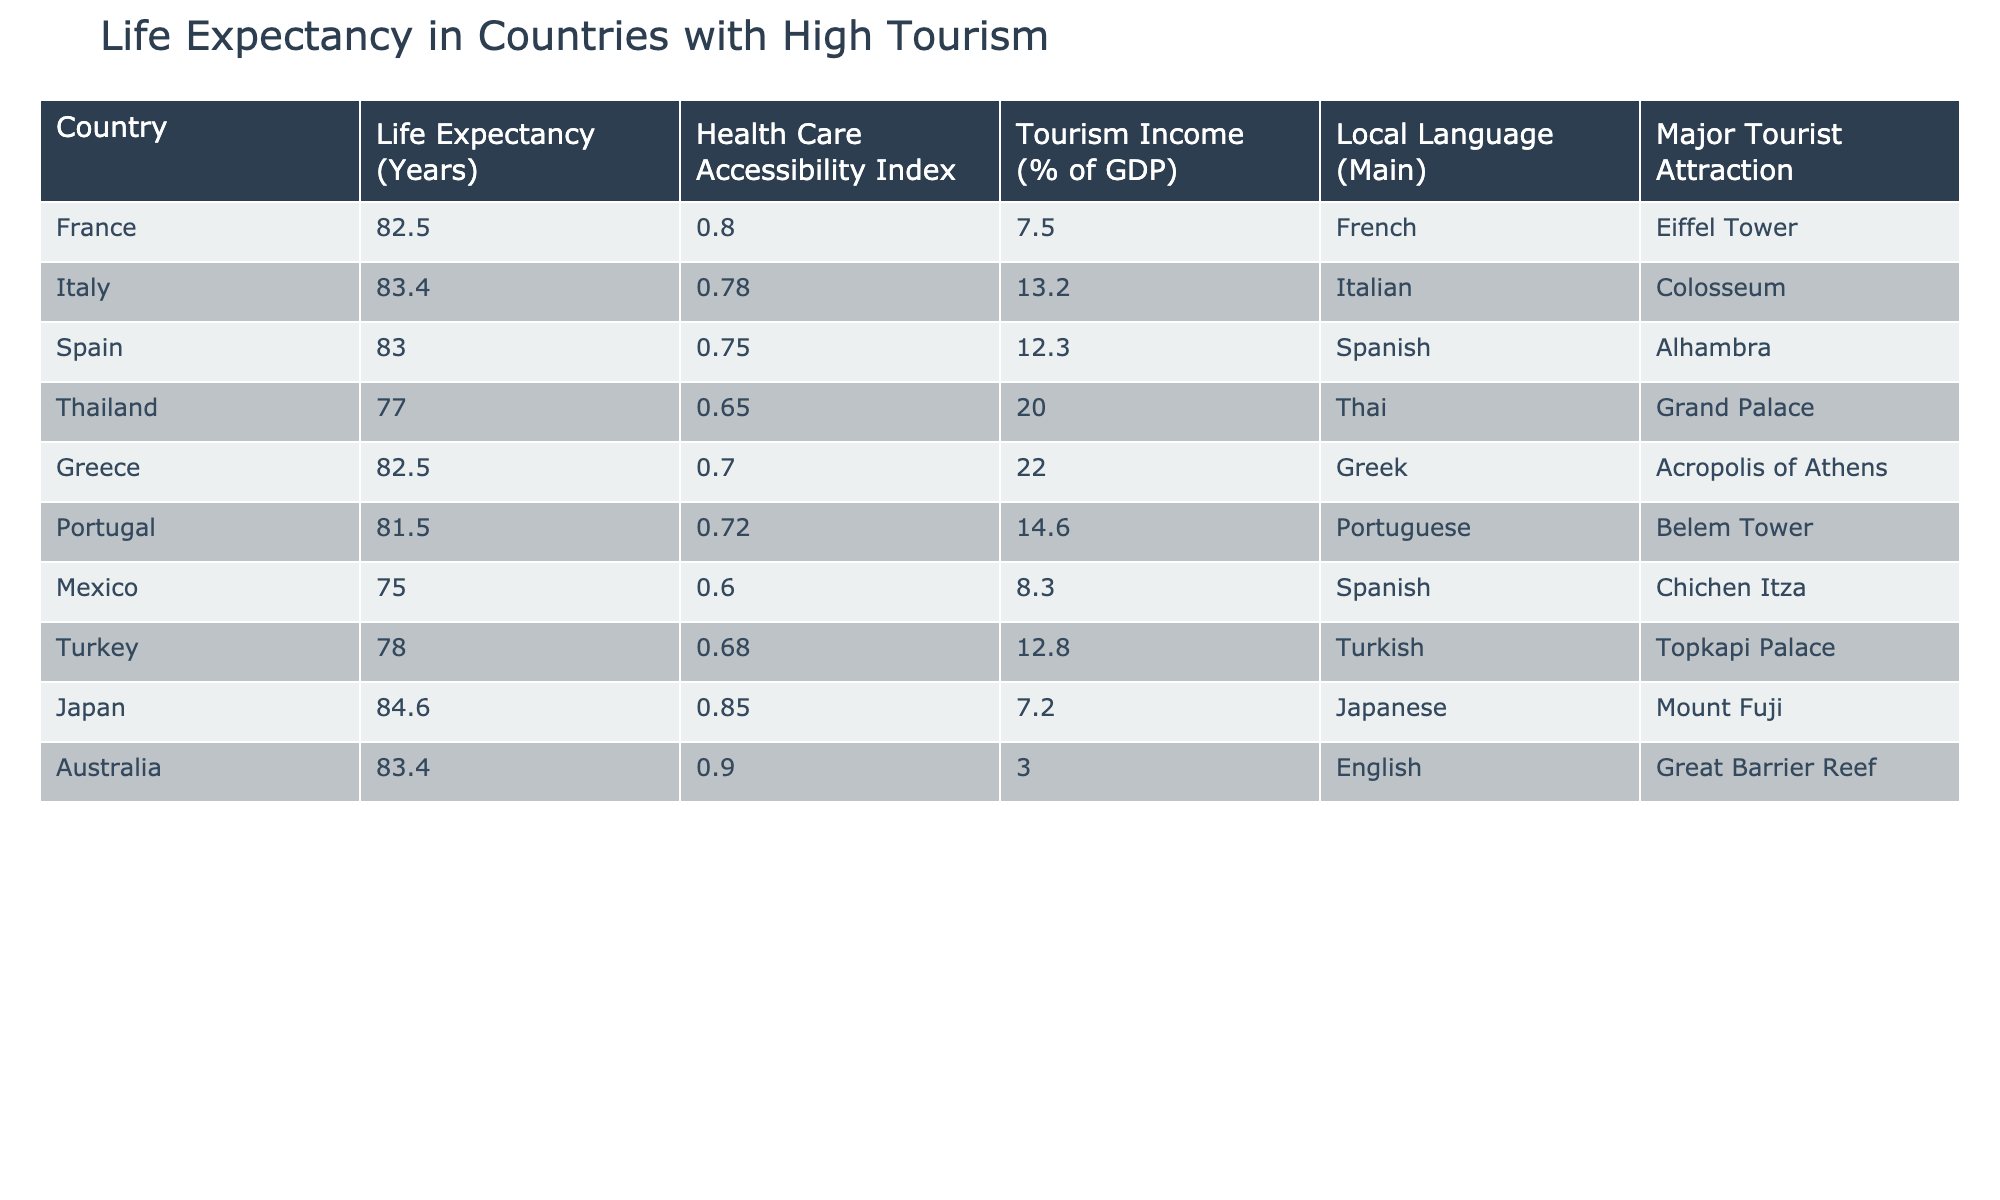What is the life expectancy of Japan? The life expectancy for Japan is directly listed in the table under the 'Life Expectancy (Years)' column for Japan, which is 84.6.
Answer: 84.6 Which country has the highest health care accessibility index? By reviewing the 'Health Care Accessibility Index' column, we see that Australia has the highest index at 0.90.
Answer: Australia What is the average life expectancy of the countries listed? To calculate the average life expectancy, we sum the life expectancy values: 82.5 + 83.4 + 83.0 + 77.0 + 82.5 + 81.5 + 75.0 + 78.0 + 84.6 + 83.4 = 824.9. There are 10 countries, so we divide 824.9 by 10, which gives us 82.49.
Answer: 82.49 Is the tourism income percentage of Spain higher than that of Mexico? The tourism income percentage for Spain is 12.3%, while for Mexico, it is 8.3%. Since 12.3 is greater than 8.3, the statement is true.
Answer: Yes Which country has both a life expectancy over 83 years and a health care accessibility index above 0.75? From the data, France (82.5 years, 0.80), Japan (84.6 years, 0.85), and Australia (83.4 years, 0.90) all meet the criteria.
Answer: France, Japan, Australia Find the difference in life expectancy between Thailand and Japan. The life expectancy in Thailand is 77.0 years, and in Japan, it is 84.6 years. We subtract 77.0 from 84.6 which gives us 84.6 - 77.0 = 7.6 years.
Answer: 7.6 Do any countries on the list have a health care accessibility index lower than 0.70? Checking the health care accessibility index, we find that both Thailand (0.65) and Mexico (0.60) have indices below 0.70. Therefore, the answer is yes.
Answer: Yes What is the tourism income percentage for Greece and how does it compare to that of Turkey? Greece has a tourism income percentage of 22.0% and Turkey has 12.8%. Comparing these, Greece's tourism income is higher than Turkey's.
Answer: Greece has 22.0%, which is higher than Turkey's 12.8% How many countries have a life expectancy between 80 and 82 years? Examining the life expectancy data, we find that Portugal (81.5), Greece (82.5), and Mexico (75.0) fall within the specified range. Portugal is the only country in this specific range, yielding a count of 1 country.
Answer: 1 